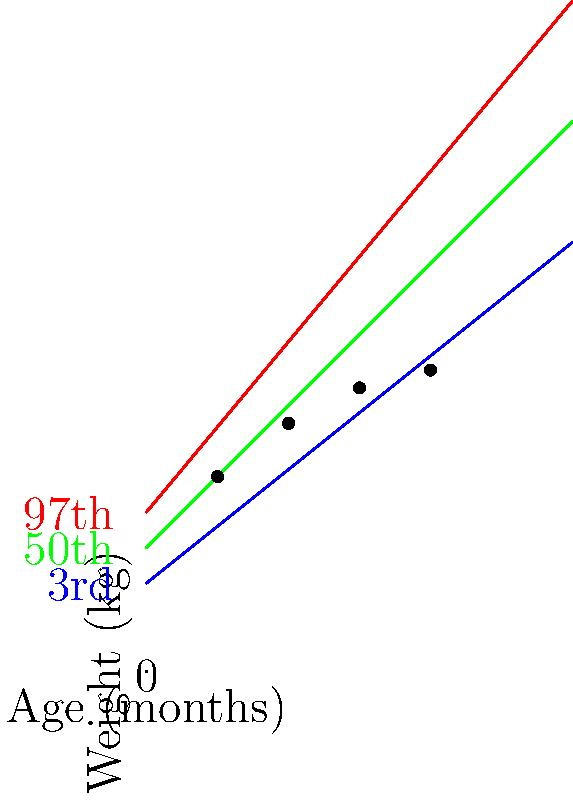Based on the baby growth chart shown, which percentile does the infant's weight most closely follow from 2 to 8 months of age? To determine which percentile the infant's weight most closely follows, we need to analyze the growth pattern:

1. At 2 months: The baby's weight (5.5 kg) is slightly above the 50th percentile line.
2. At 4 months: The baby's weight (7 kg) has moved closer to the 97th percentile line.
3. At 6 months: The baby's weight (8 kg) is now very close to the 97th percentile line.
4. At 8 months: The baby's weight (8.5 kg) remains close to the 97th percentile line.

The infant's growth pattern shows a consistent trend of moving towards and then following the 97th percentile line. While the growth starts closer to the 50th percentile, it quickly approaches and maintains a trajectory near the 97th percentile for the majority of the observed period.

This growth pattern indicates rapid weight gain in the first few months, followed by a more stable growth rate that aligns closely with the 97th percentile curve.
Answer: 97th percentile 